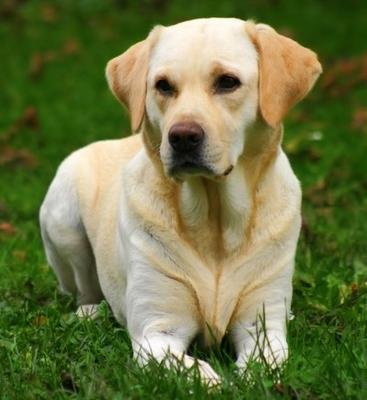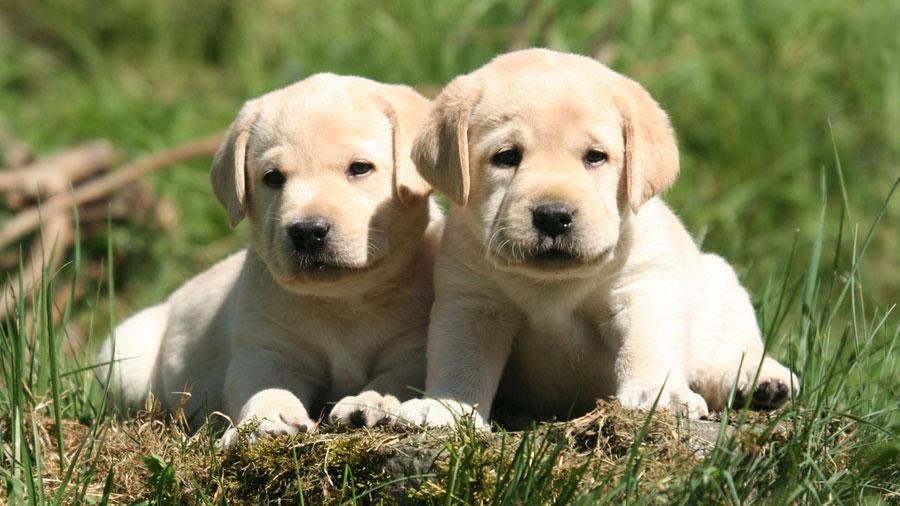The first image is the image on the left, the second image is the image on the right. Considering the images on both sides, is "The right image shows exactly two puppies side by side." valid? Answer yes or no. Yes. 